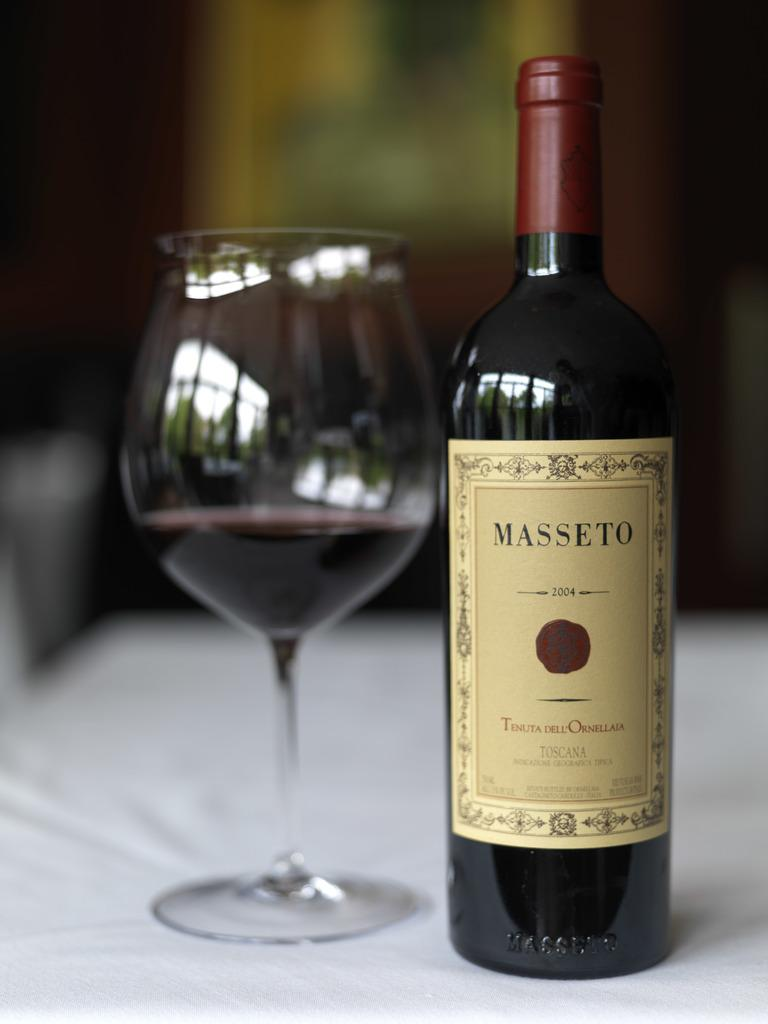<image>
Provide a brief description of the given image. A bottle of Masseto wine sits next to a glass on a white tablecloth. 